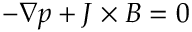<formula> <loc_0><loc_0><loc_500><loc_500>- \nabla p + J \times B = 0</formula> 